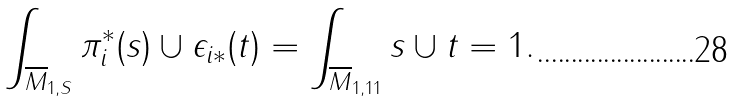<formula> <loc_0><loc_0><loc_500><loc_500>\int _ { \overline { M } _ { 1 , S } } \pi ^ { * } _ { i } ( s ) \cup \epsilon _ { i * } ( t ) = \int _ { \overline { M } _ { 1 , 1 1 } } s \cup t = 1 .</formula> 